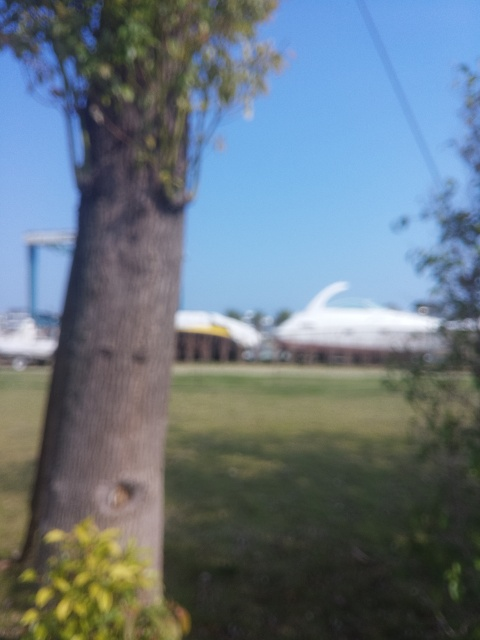Is the focusing accurate?
A. Yes
B. No
Answer with the option's letter from the given choices directly.
 B. 